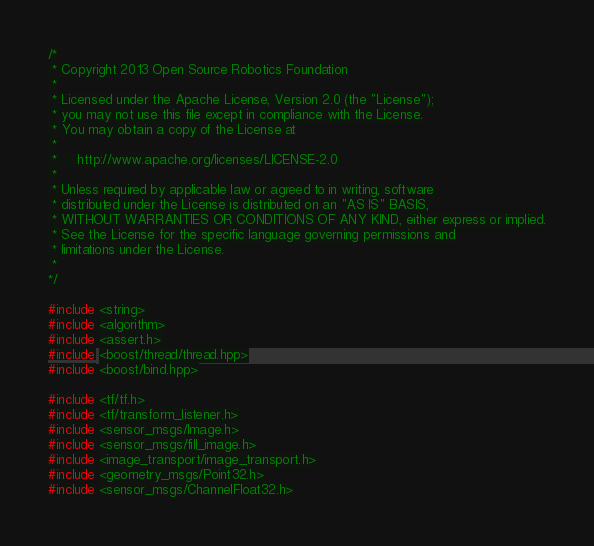Convert code to text. <code><loc_0><loc_0><loc_500><loc_500><_C++_>/*
 * Copyright 2013 Open Source Robotics Foundation
 *
 * Licensed under the Apache License, Version 2.0 (the "License");
 * you may not use this file except in compliance with the License.
 * You may obtain a copy of the License at
 *
 *     http://www.apache.org/licenses/LICENSE-2.0
 *
 * Unless required by applicable law or agreed to in writing, software
 * distributed under the License is distributed on an "AS IS" BASIS,
 * WITHOUT WARRANTIES OR CONDITIONS OF ANY KIND, either express or implied.
 * See the License for the specific language governing permissions and
 * limitations under the License.
 *
*/

#include <string>
#include <algorithm>
#include <assert.h>
#include <boost/thread/thread.hpp>
#include <boost/bind.hpp>

#include <tf/tf.h>
#include <tf/transform_listener.h>
#include <sensor_msgs/Image.h>
#include <sensor_msgs/fill_image.h>
#include <image_transport/image_transport.h>
#include <geometry_msgs/Point32.h>
#include <sensor_msgs/ChannelFloat32.h></code> 